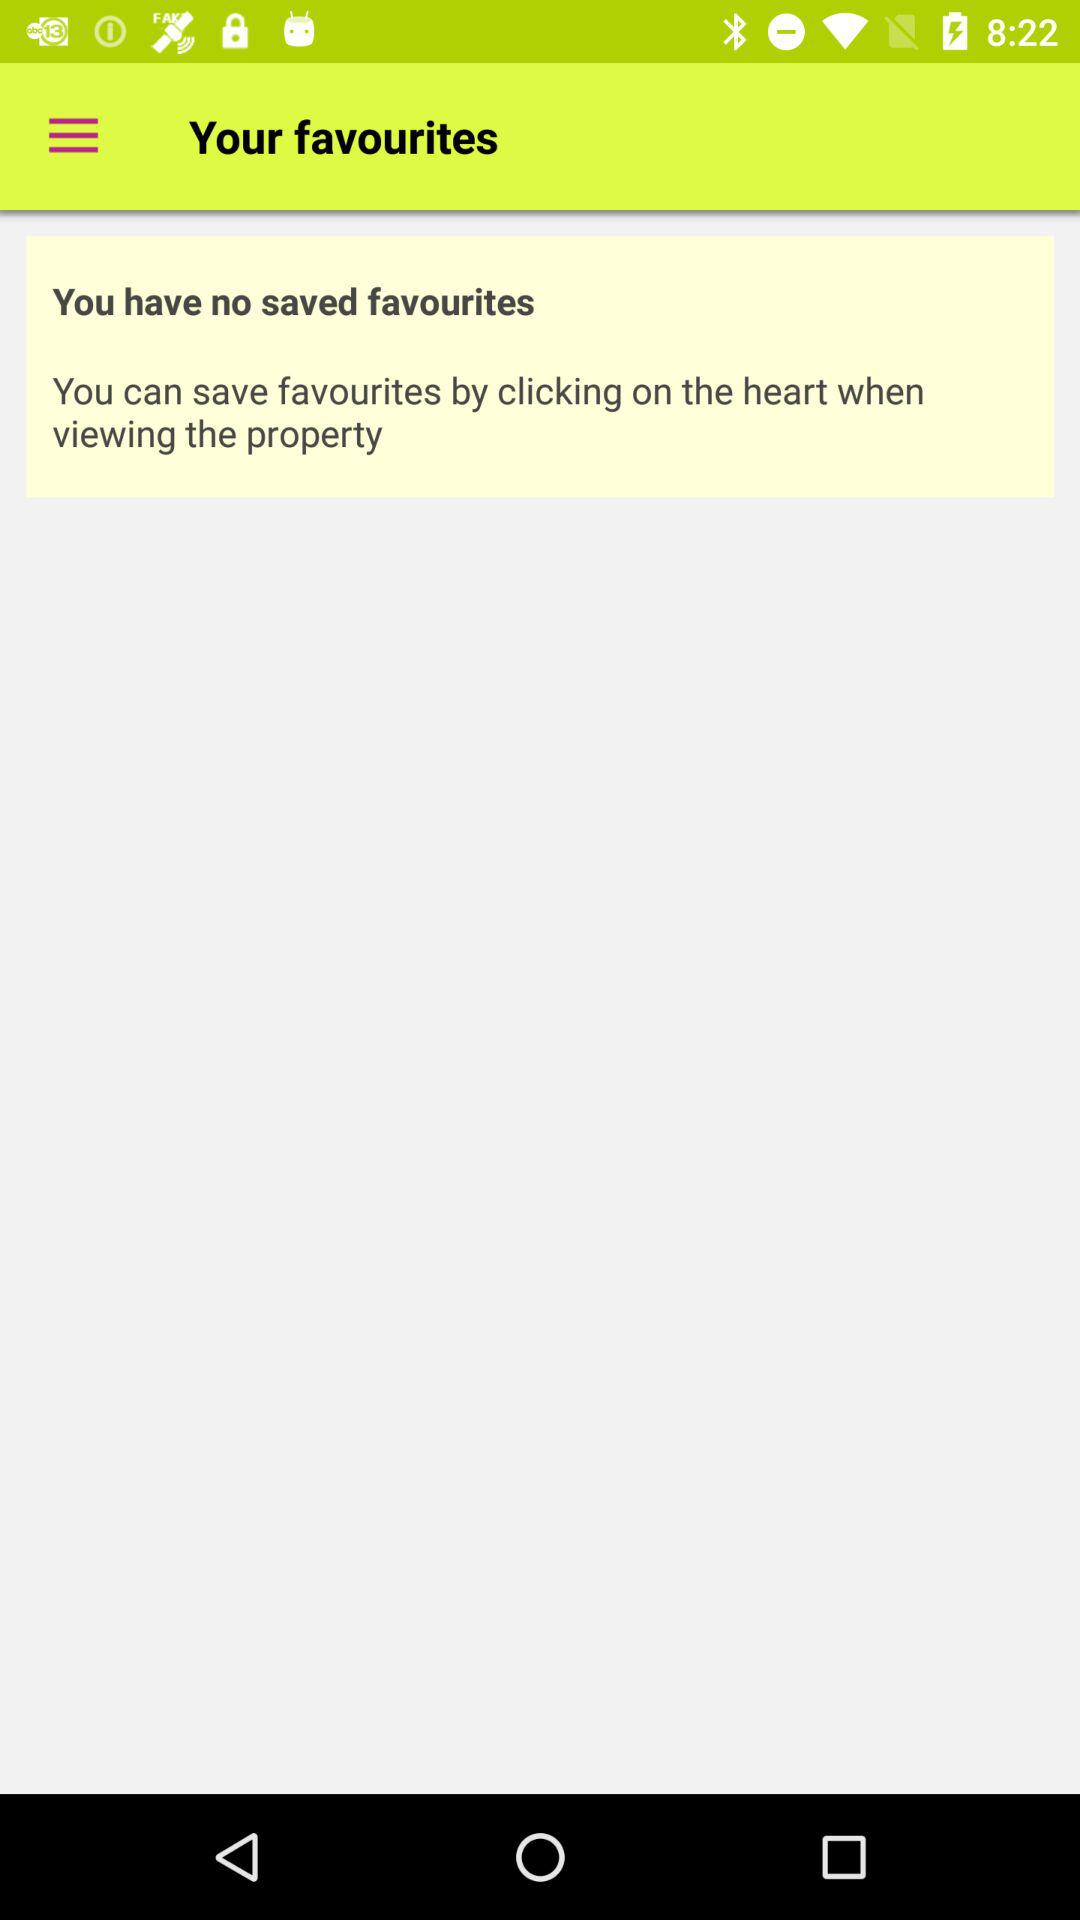Are there any saved favourites? There is no saved favourite. 